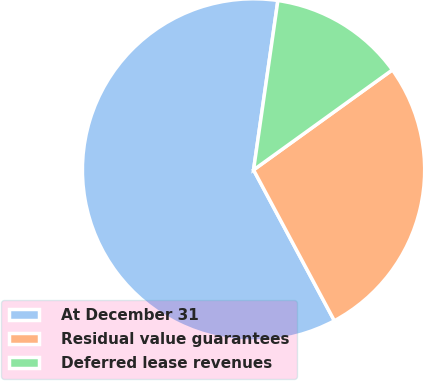Convert chart. <chart><loc_0><loc_0><loc_500><loc_500><pie_chart><fcel>At December 31<fcel>Residual value guarantees<fcel>Deferred lease revenues<nl><fcel>60.1%<fcel>27.11%<fcel>12.79%<nl></chart> 